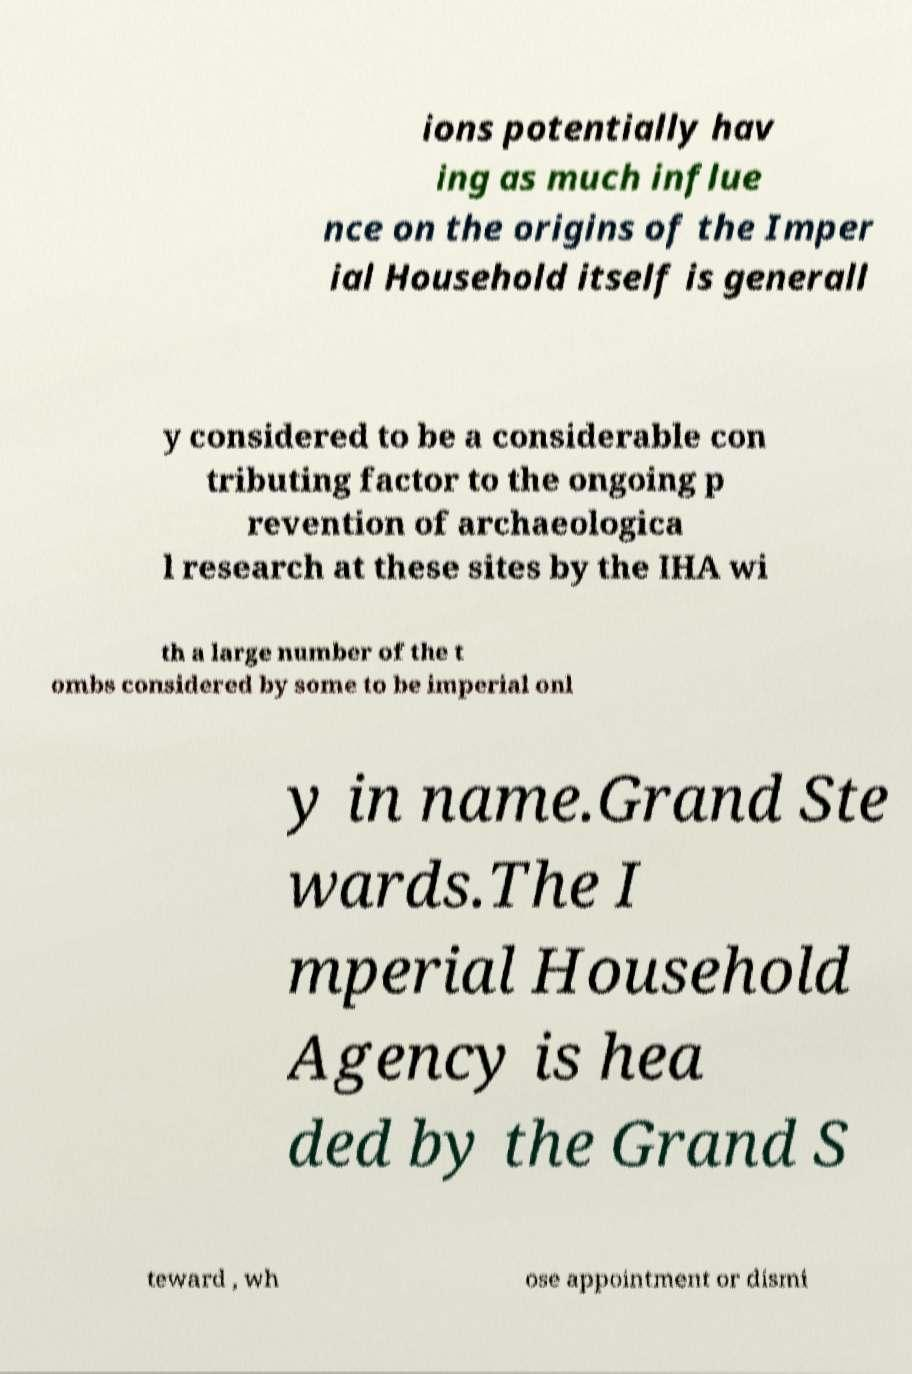Could you extract and type out the text from this image? ions potentially hav ing as much influe nce on the origins of the Imper ial Household itself is generall y considered to be a considerable con tributing factor to the ongoing p revention of archaeologica l research at these sites by the IHA wi th a large number of the t ombs considered by some to be imperial onl y in name.Grand Ste wards.The I mperial Household Agency is hea ded by the Grand S teward , wh ose appointment or dismi 